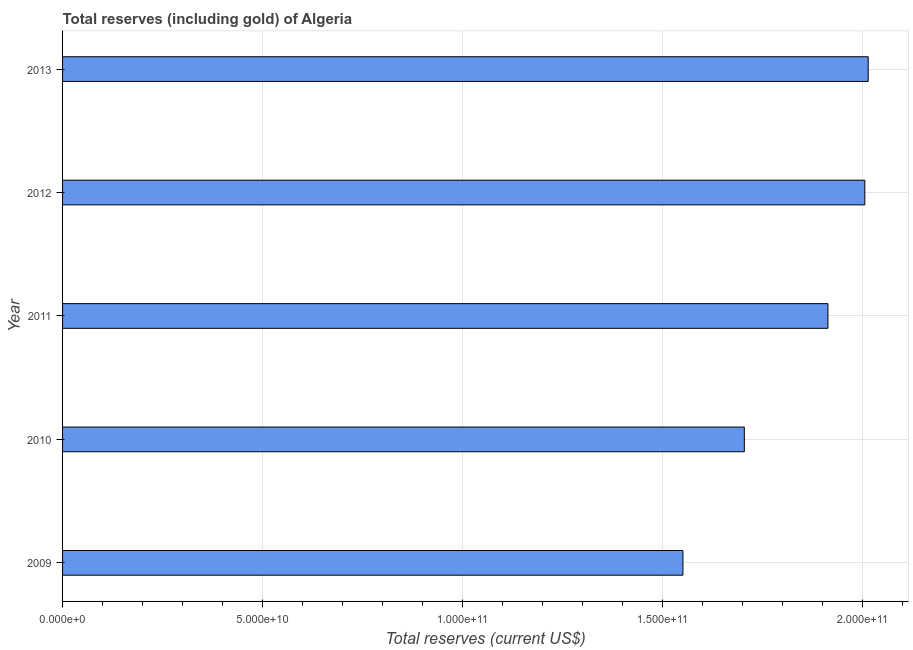Does the graph contain any zero values?
Make the answer very short. No. Does the graph contain grids?
Keep it short and to the point. Yes. What is the title of the graph?
Your answer should be compact. Total reserves (including gold) of Algeria. What is the label or title of the X-axis?
Make the answer very short. Total reserves (current US$). What is the total reserves (including gold) in 2011?
Give a very brief answer. 1.91e+11. Across all years, what is the maximum total reserves (including gold)?
Your response must be concise. 2.01e+11. Across all years, what is the minimum total reserves (including gold)?
Your answer should be very brief. 1.55e+11. In which year was the total reserves (including gold) minimum?
Ensure brevity in your answer.  2009. What is the sum of the total reserves (including gold)?
Give a very brief answer. 9.19e+11. What is the difference between the total reserves (including gold) in 2009 and 2013?
Provide a succinct answer. -4.63e+1. What is the average total reserves (including gold) per year?
Provide a short and direct response. 1.84e+11. What is the median total reserves (including gold)?
Provide a succinct answer. 1.91e+11. What is the ratio of the total reserves (including gold) in 2010 to that in 2011?
Provide a short and direct response. 0.89. Is the difference between the total reserves (including gold) in 2011 and 2013 greater than the difference between any two years?
Give a very brief answer. No. What is the difference between the highest and the second highest total reserves (including gold)?
Your answer should be compact. 8.50e+08. Is the sum of the total reserves (including gold) in 2012 and 2013 greater than the maximum total reserves (including gold) across all years?
Your answer should be compact. Yes. What is the difference between the highest and the lowest total reserves (including gold)?
Offer a very short reply. 4.63e+1. In how many years, is the total reserves (including gold) greater than the average total reserves (including gold) taken over all years?
Give a very brief answer. 3. Are all the bars in the graph horizontal?
Make the answer very short. Yes. How many years are there in the graph?
Provide a succinct answer. 5. Are the values on the major ticks of X-axis written in scientific E-notation?
Offer a terse response. Yes. What is the Total reserves (current US$) of 2009?
Your answer should be very brief. 1.55e+11. What is the Total reserves (current US$) in 2010?
Keep it short and to the point. 1.70e+11. What is the Total reserves (current US$) of 2011?
Ensure brevity in your answer.  1.91e+11. What is the Total reserves (current US$) of 2012?
Provide a succinct answer. 2.01e+11. What is the Total reserves (current US$) of 2013?
Offer a very short reply. 2.01e+11. What is the difference between the Total reserves (current US$) in 2009 and 2010?
Offer a terse response. -1.53e+1. What is the difference between the Total reserves (current US$) in 2009 and 2011?
Ensure brevity in your answer.  -3.63e+1. What is the difference between the Total reserves (current US$) in 2009 and 2012?
Offer a terse response. -4.55e+1. What is the difference between the Total reserves (current US$) in 2009 and 2013?
Ensure brevity in your answer.  -4.63e+1. What is the difference between the Total reserves (current US$) in 2010 and 2011?
Make the answer very short. -2.09e+1. What is the difference between the Total reserves (current US$) in 2010 and 2012?
Keep it short and to the point. -3.01e+1. What is the difference between the Total reserves (current US$) in 2010 and 2013?
Your answer should be very brief. -3.10e+1. What is the difference between the Total reserves (current US$) in 2011 and 2012?
Offer a very short reply. -9.22e+09. What is the difference between the Total reserves (current US$) in 2011 and 2013?
Offer a very short reply. -1.01e+1. What is the difference between the Total reserves (current US$) in 2012 and 2013?
Ensure brevity in your answer.  -8.50e+08. What is the ratio of the Total reserves (current US$) in 2009 to that in 2010?
Provide a succinct answer. 0.91. What is the ratio of the Total reserves (current US$) in 2009 to that in 2011?
Your answer should be very brief. 0.81. What is the ratio of the Total reserves (current US$) in 2009 to that in 2012?
Offer a very short reply. 0.77. What is the ratio of the Total reserves (current US$) in 2009 to that in 2013?
Your answer should be compact. 0.77. What is the ratio of the Total reserves (current US$) in 2010 to that in 2011?
Offer a very short reply. 0.89. What is the ratio of the Total reserves (current US$) in 2010 to that in 2013?
Make the answer very short. 0.85. What is the ratio of the Total reserves (current US$) in 2011 to that in 2012?
Provide a succinct answer. 0.95. What is the ratio of the Total reserves (current US$) in 2011 to that in 2013?
Keep it short and to the point. 0.95. 